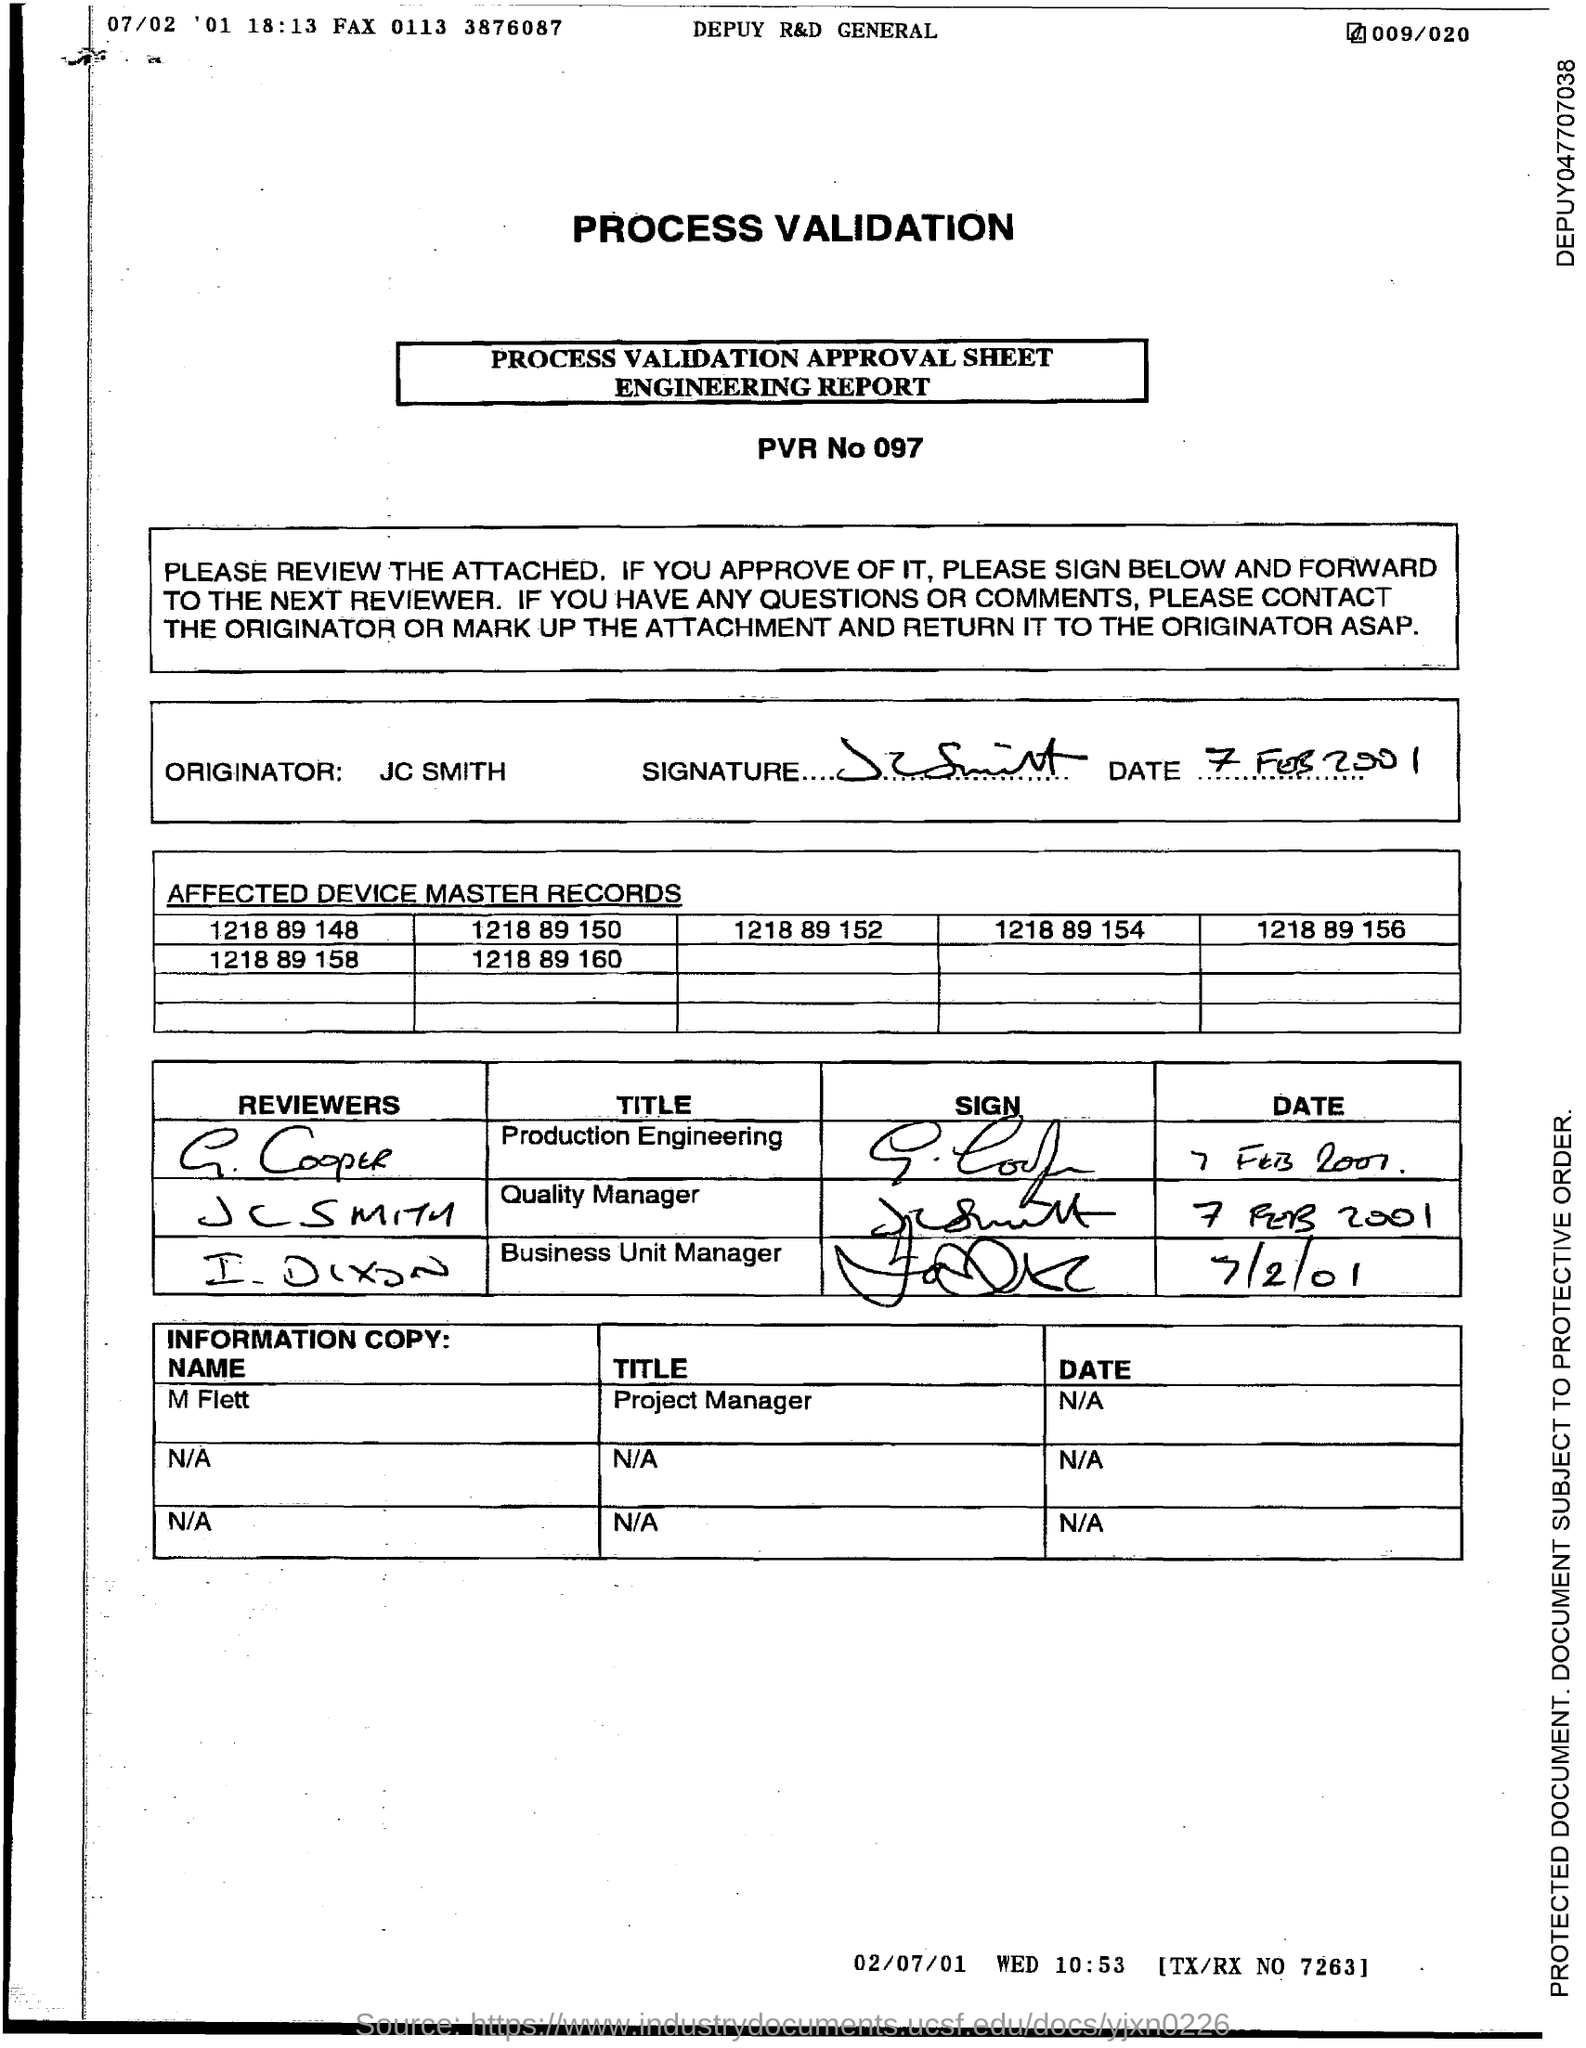Indicate a few pertinent items in this graphic. M Flett is a project manager, and the title of their work is [insert title here]. I would like to inquire about the PVR number. Specifically, I am requesting the PVR number for the call I am currently on. The PVR number is 097.. 